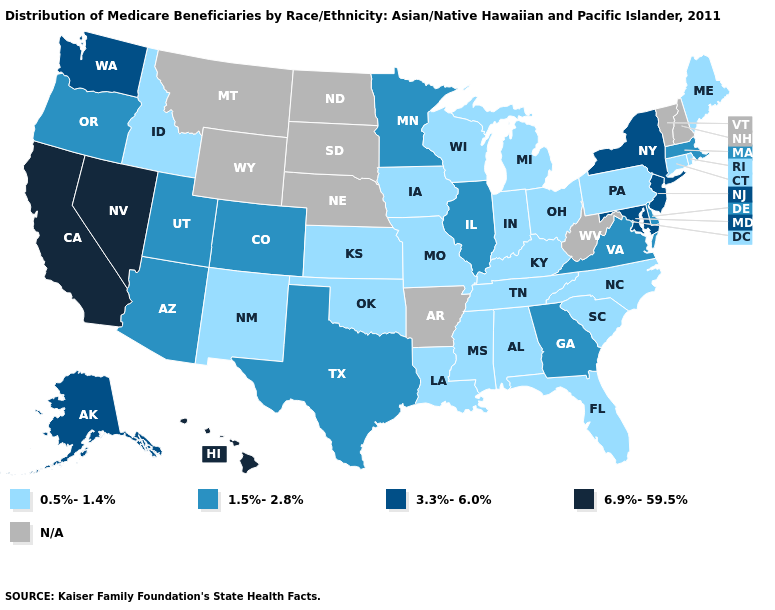Name the states that have a value in the range N/A?
Be succinct. Arkansas, Montana, Nebraska, New Hampshire, North Dakota, South Dakota, Vermont, West Virginia, Wyoming. What is the value of Rhode Island?
Be succinct. 0.5%-1.4%. What is the highest value in the Northeast ?
Keep it brief. 3.3%-6.0%. What is the highest value in the Northeast ?
Keep it brief. 3.3%-6.0%. Among the states that border New Hampshire , does Maine have the highest value?
Concise answer only. No. What is the lowest value in the USA?
Concise answer only. 0.5%-1.4%. Name the states that have a value in the range N/A?
Write a very short answer. Arkansas, Montana, Nebraska, New Hampshire, North Dakota, South Dakota, Vermont, West Virginia, Wyoming. Name the states that have a value in the range 1.5%-2.8%?
Write a very short answer. Arizona, Colorado, Delaware, Georgia, Illinois, Massachusetts, Minnesota, Oregon, Texas, Utah, Virginia. What is the highest value in states that border West Virginia?
Give a very brief answer. 3.3%-6.0%. Which states have the lowest value in the Northeast?
Write a very short answer. Connecticut, Maine, Pennsylvania, Rhode Island. Name the states that have a value in the range 3.3%-6.0%?
Concise answer only. Alaska, Maryland, New Jersey, New York, Washington. Name the states that have a value in the range N/A?
Write a very short answer. Arkansas, Montana, Nebraska, New Hampshire, North Dakota, South Dakota, Vermont, West Virginia, Wyoming. Among the states that border Nevada , which have the lowest value?
Write a very short answer. Idaho. What is the lowest value in the Northeast?
Quick response, please. 0.5%-1.4%. 